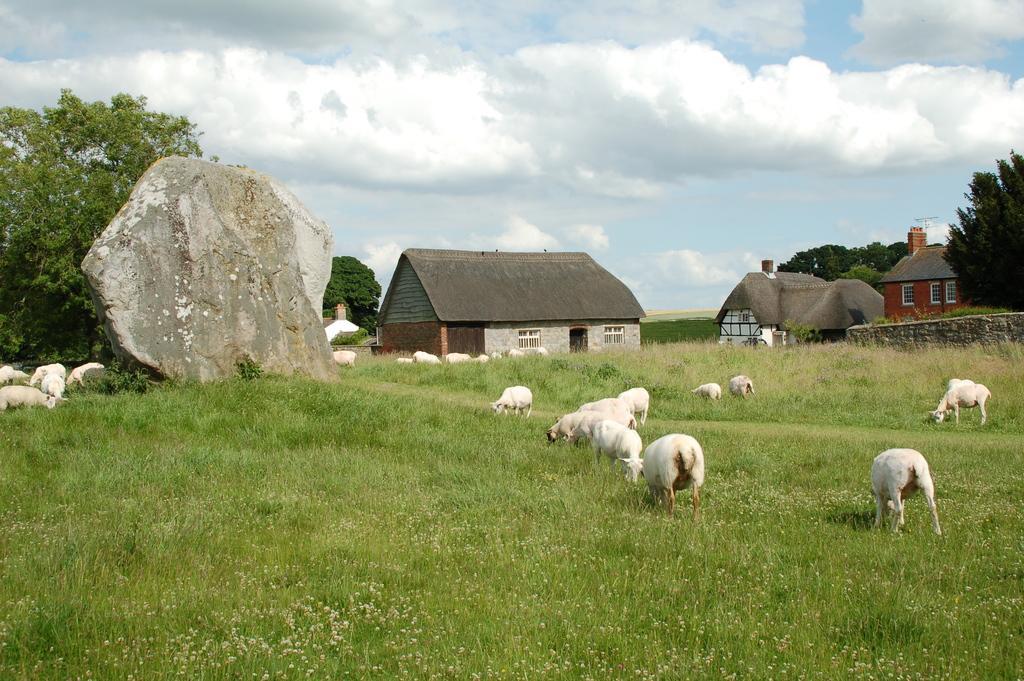Describe this image in one or two sentences. In this picture we can see sheep in the field, in the background we can see few trees, houses, rocks and clouds. 